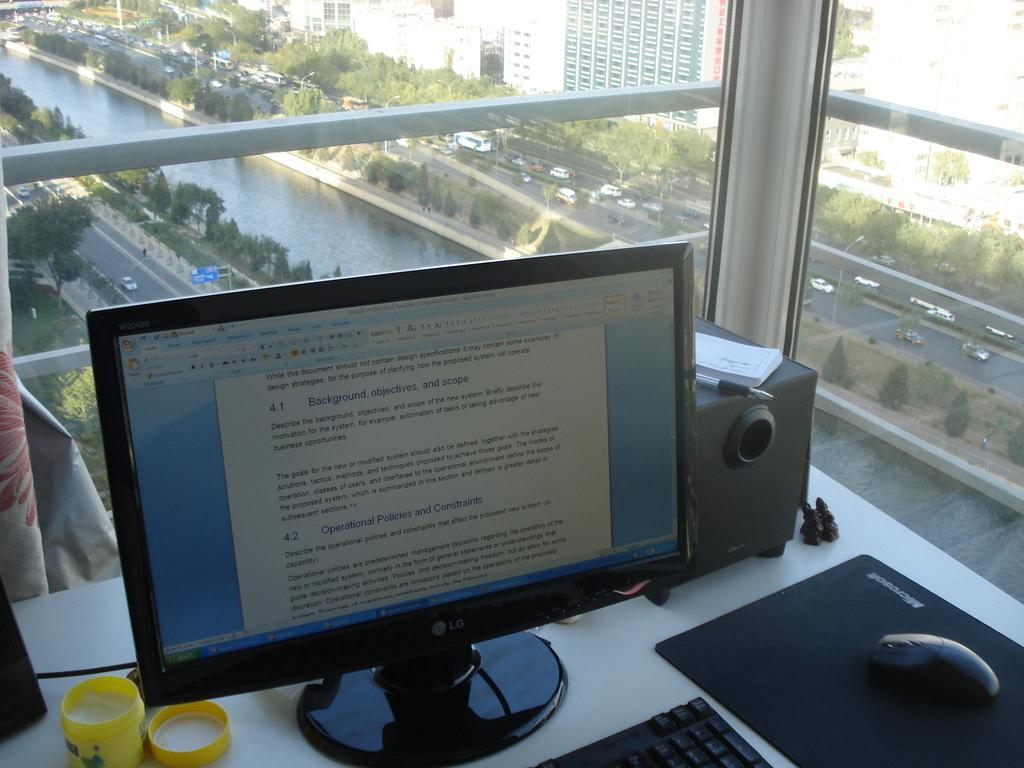What brand is the monitor?
Make the answer very short. Lg. What number is on the second blue line?
Offer a very short reply. 4.2. 